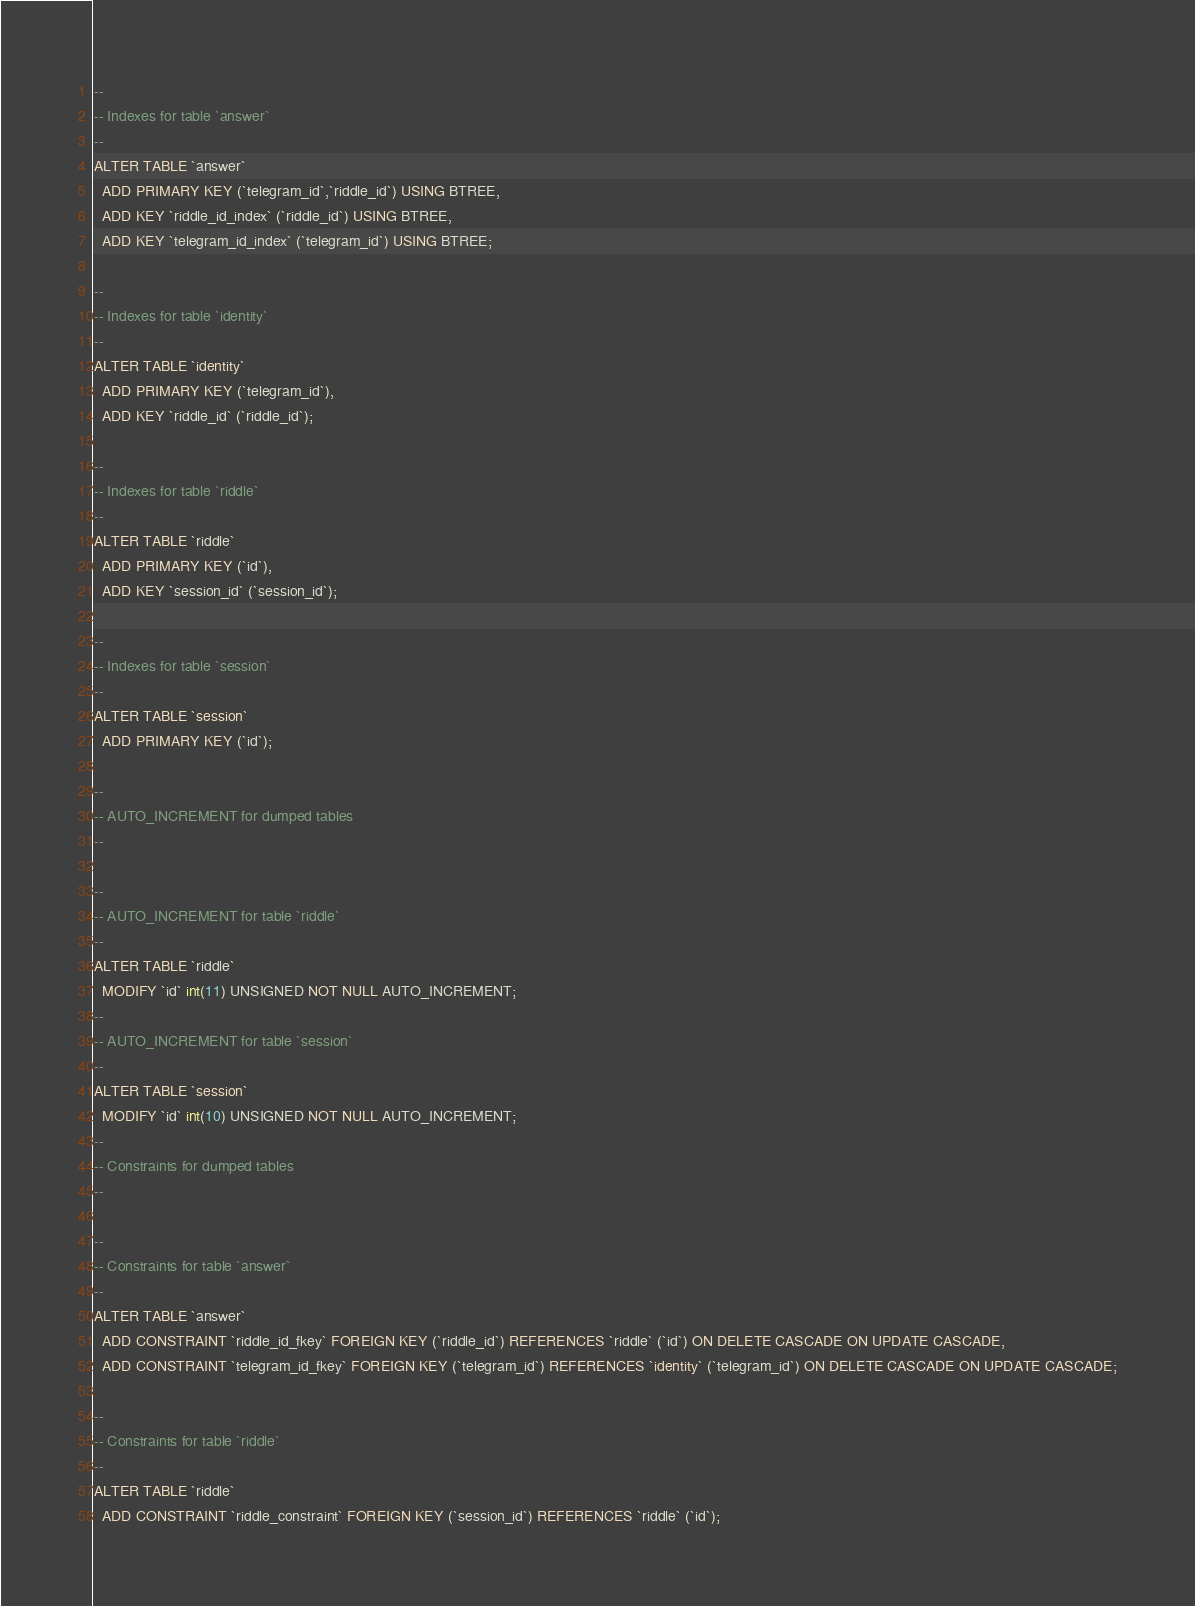<code> <loc_0><loc_0><loc_500><loc_500><_SQL_>--
-- Indexes for table `answer`
--
ALTER TABLE `answer`
  ADD PRIMARY KEY (`telegram_id`,`riddle_id`) USING BTREE,
  ADD KEY `riddle_id_index` (`riddle_id`) USING BTREE,
  ADD KEY `telegram_id_index` (`telegram_id`) USING BTREE;

--
-- Indexes for table `identity`
--
ALTER TABLE `identity`
  ADD PRIMARY KEY (`telegram_id`),
  ADD KEY `riddle_id` (`riddle_id`);

--
-- Indexes for table `riddle`
--
ALTER TABLE `riddle`
  ADD PRIMARY KEY (`id`),
  ADD KEY `session_id` (`session_id`);

--
-- Indexes for table `session`
--
ALTER TABLE `session`
  ADD PRIMARY KEY (`id`);

--
-- AUTO_INCREMENT for dumped tables
--

--
-- AUTO_INCREMENT for table `riddle`
--
ALTER TABLE `riddle`
  MODIFY `id` int(11) UNSIGNED NOT NULL AUTO_INCREMENT;
--
-- AUTO_INCREMENT for table `session`
--
ALTER TABLE `session`
  MODIFY `id` int(10) UNSIGNED NOT NULL AUTO_INCREMENT;
--
-- Constraints for dumped tables
--

--
-- Constraints for table `answer`
--
ALTER TABLE `answer`
  ADD CONSTRAINT `riddle_id_fkey` FOREIGN KEY (`riddle_id`) REFERENCES `riddle` (`id`) ON DELETE CASCADE ON UPDATE CASCADE,
  ADD CONSTRAINT `telegram_id_fkey` FOREIGN KEY (`telegram_id`) REFERENCES `identity` (`telegram_id`) ON DELETE CASCADE ON UPDATE CASCADE;

--
-- Constraints for table `riddle`
--
ALTER TABLE `riddle`
  ADD CONSTRAINT `riddle_constraint` FOREIGN KEY (`session_id`) REFERENCES `riddle` (`id`);
</code> 